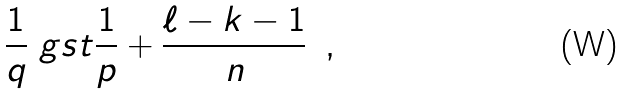<formula> <loc_0><loc_0><loc_500><loc_500>\frac { 1 } { q } \ g s t \frac { 1 } { p } + \frac { \ell - k - 1 } { n } \ \, ,</formula> 